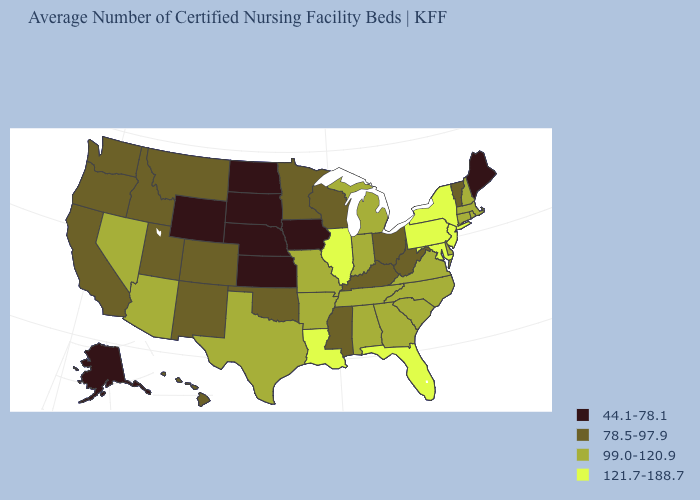What is the value of Maine?
Concise answer only. 44.1-78.1. Among the states that border North Carolina , which have the highest value?
Short answer required. Georgia, South Carolina, Tennessee, Virginia. What is the value of California?
Quick response, please. 78.5-97.9. What is the highest value in the MidWest ?
Answer briefly. 121.7-188.7. Name the states that have a value in the range 78.5-97.9?
Give a very brief answer. California, Colorado, Hawaii, Idaho, Kentucky, Minnesota, Mississippi, Montana, New Mexico, Ohio, Oklahoma, Oregon, Utah, Vermont, Washington, West Virginia, Wisconsin. What is the highest value in states that border Wisconsin?
Concise answer only. 121.7-188.7. Which states have the lowest value in the USA?
Be succinct. Alaska, Iowa, Kansas, Maine, Nebraska, North Dakota, South Dakota, Wyoming. What is the lowest value in the MidWest?
Answer briefly. 44.1-78.1. Which states hav the highest value in the South?
Quick response, please. Florida, Louisiana, Maryland. Name the states that have a value in the range 121.7-188.7?
Be succinct. Florida, Illinois, Louisiana, Maryland, New Jersey, New York, Pennsylvania. What is the lowest value in the USA?
Keep it brief. 44.1-78.1. Does Massachusetts have the lowest value in the Northeast?
Short answer required. No. Which states have the lowest value in the West?
Keep it brief. Alaska, Wyoming. Name the states that have a value in the range 44.1-78.1?
Keep it brief. Alaska, Iowa, Kansas, Maine, Nebraska, North Dakota, South Dakota, Wyoming. What is the value of Mississippi?
Write a very short answer. 78.5-97.9. 